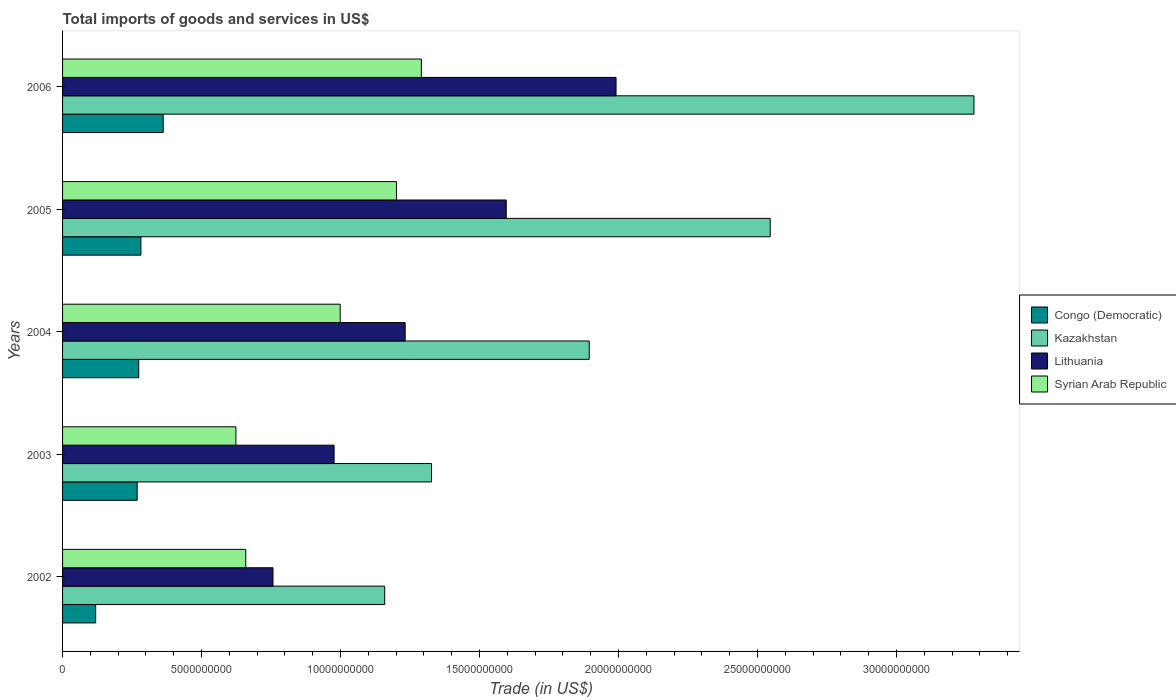Are the number of bars per tick equal to the number of legend labels?
Keep it short and to the point. Yes. How many bars are there on the 2nd tick from the top?
Give a very brief answer. 4. How many bars are there on the 1st tick from the bottom?
Your response must be concise. 4. What is the total imports of goods and services in Congo (Democratic) in 2006?
Ensure brevity in your answer.  3.62e+09. Across all years, what is the maximum total imports of goods and services in Congo (Democratic)?
Provide a short and direct response. 3.62e+09. Across all years, what is the minimum total imports of goods and services in Congo (Democratic)?
Ensure brevity in your answer.  1.19e+09. In which year was the total imports of goods and services in Kazakhstan maximum?
Offer a very short reply. 2006. What is the total total imports of goods and services in Lithuania in the graph?
Give a very brief answer. 6.55e+1. What is the difference between the total imports of goods and services in Congo (Democratic) in 2004 and that in 2005?
Keep it short and to the point. -7.91e+07. What is the difference between the total imports of goods and services in Lithuania in 2005 and the total imports of goods and services in Congo (Democratic) in 2003?
Your answer should be compact. 1.33e+1. What is the average total imports of goods and services in Kazakhstan per year?
Offer a very short reply. 2.04e+1. In the year 2006, what is the difference between the total imports of goods and services in Congo (Democratic) and total imports of goods and services in Kazakhstan?
Your answer should be compact. -2.92e+1. What is the ratio of the total imports of goods and services in Congo (Democratic) in 2003 to that in 2006?
Provide a succinct answer. 0.74. Is the total imports of goods and services in Lithuania in 2002 less than that in 2006?
Keep it short and to the point. Yes. Is the difference between the total imports of goods and services in Congo (Democratic) in 2002 and 2004 greater than the difference between the total imports of goods and services in Kazakhstan in 2002 and 2004?
Provide a short and direct response. Yes. What is the difference between the highest and the second highest total imports of goods and services in Kazakhstan?
Give a very brief answer. 7.33e+09. What is the difference between the highest and the lowest total imports of goods and services in Kazakhstan?
Provide a succinct answer. 2.12e+1. In how many years, is the total imports of goods and services in Syrian Arab Republic greater than the average total imports of goods and services in Syrian Arab Republic taken over all years?
Your answer should be very brief. 3. Is the sum of the total imports of goods and services in Kazakhstan in 2002 and 2006 greater than the maximum total imports of goods and services in Lithuania across all years?
Offer a terse response. Yes. Is it the case that in every year, the sum of the total imports of goods and services in Syrian Arab Republic and total imports of goods and services in Lithuania is greater than the sum of total imports of goods and services in Congo (Democratic) and total imports of goods and services in Kazakhstan?
Give a very brief answer. No. What does the 4th bar from the top in 2006 represents?
Keep it short and to the point. Congo (Democratic). What does the 1st bar from the bottom in 2004 represents?
Your answer should be compact. Congo (Democratic). Does the graph contain grids?
Ensure brevity in your answer.  No. How many legend labels are there?
Your answer should be very brief. 4. What is the title of the graph?
Keep it short and to the point. Total imports of goods and services in US$. What is the label or title of the X-axis?
Your answer should be compact. Trade (in US$). What is the Trade (in US$) in Congo (Democratic) in 2002?
Provide a succinct answer. 1.19e+09. What is the Trade (in US$) of Kazakhstan in 2002?
Your response must be concise. 1.16e+1. What is the Trade (in US$) in Lithuania in 2002?
Provide a succinct answer. 7.57e+09. What is the Trade (in US$) in Syrian Arab Republic in 2002?
Give a very brief answer. 6.59e+09. What is the Trade (in US$) of Congo (Democratic) in 2003?
Your response must be concise. 2.68e+09. What is the Trade (in US$) in Kazakhstan in 2003?
Offer a terse response. 1.33e+1. What is the Trade (in US$) of Lithuania in 2003?
Your response must be concise. 9.77e+09. What is the Trade (in US$) of Syrian Arab Republic in 2003?
Your response must be concise. 6.24e+09. What is the Trade (in US$) in Congo (Democratic) in 2004?
Give a very brief answer. 2.74e+09. What is the Trade (in US$) of Kazakhstan in 2004?
Offer a terse response. 1.89e+1. What is the Trade (in US$) of Lithuania in 2004?
Keep it short and to the point. 1.23e+1. What is the Trade (in US$) of Syrian Arab Republic in 2004?
Keep it short and to the point. 9.99e+09. What is the Trade (in US$) of Congo (Democratic) in 2005?
Provide a succinct answer. 2.82e+09. What is the Trade (in US$) in Kazakhstan in 2005?
Your answer should be very brief. 2.55e+1. What is the Trade (in US$) in Lithuania in 2005?
Provide a short and direct response. 1.60e+1. What is the Trade (in US$) in Syrian Arab Republic in 2005?
Your answer should be very brief. 1.20e+1. What is the Trade (in US$) in Congo (Democratic) in 2006?
Ensure brevity in your answer.  3.62e+09. What is the Trade (in US$) in Kazakhstan in 2006?
Provide a succinct answer. 3.28e+1. What is the Trade (in US$) in Lithuania in 2006?
Your answer should be very brief. 1.99e+1. What is the Trade (in US$) in Syrian Arab Republic in 2006?
Keep it short and to the point. 1.29e+1. Across all years, what is the maximum Trade (in US$) of Congo (Democratic)?
Your response must be concise. 3.62e+09. Across all years, what is the maximum Trade (in US$) in Kazakhstan?
Make the answer very short. 3.28e+1. Across all years, what is the maximum Trade (in US$) in Lithuania?
Make the answer very short. 1.99e+1. Across all years, what is the maximum Trade (in US$) in Syrian Arab Republic?
Offer a terse response. 1.29e+1. Across all years, what is the minimum Trade (in US$) in Congo (Democratic)?
Keep it short and to the point. 1.19e+09. Across all years, what is the minimum Trade (in US$) in Kazakhstan?
Offer a very short reply. 1.16e+1. Across all years, what is the minimum Trade (in US$) in Lithuania?
Provide a short and direct response. 7.57e+09. Across all years, what is the minimum Trade (in US$) of Syrian Arab Republic?
Your answer should be very brief. 6.24e+09. What is the total Trade (in US$) of Congo (Democratic) in the graph?
Give a very brief answer. 1.31e+1. What is the total Trade (in US$) in Kazakhstan in the graph?
Offer a terse response. 1.02e+11. What is the total Trade (in US$) of Lithuania in the graph?
Provide a succinct answer. 6.55e+1. What is the total Trade (in US$) in Syrian Arab Republic in the graph?
Give a very brief answer. 4.77e+1. What is the difference between the Trade (in US$) in Congo (Democratic) in 2002 and that in 2003?
Provide a succinct answer. -1.49e+09. What is the difference between the Trade (in US$) of Kazakhstan in 2002 and that in 2003?
Give a very brief answer. -1.68e+09. What is the difference between the Trade (in US$) in Lithuania in 2002 and that in 2003?
Offer a terse response. -2.20e+09. What is the difference between the Trade (in US$) in Syrian Arab Republic in 2002 and that in 2003?
Your response must be concise. 3.56e+08. What is the difference between the Trade (in US$) in Congo (Democratic) in 2002 and that in 2004?
Provide a succinct answer. -1.55e+09. What is the difference between the Trade (in US$) in Kazakhstan in 2002 and that in 2004?
Offer a terse response. -7.36e+09. What is the difference between the Trade (in US$) of Lithuania in 2002 and that in 2004?
Make the answer very short. -4.76e+09. What is the difference between the Trade (in US$) of Syrian Arab Republic in 2002 and that in 2004?
Ensure brevity in your answer.  -3.40e+09. What is the difference between the Trade (in US$) of Congo (Democratic) in 2002 and that in 2005?
Your response must be concise. -1.63e+09. What is the difference between the Trade (in US$) of Kazakhstan in 2002 and that in 2005?
Your answer should be very brief. -1.39e+1. What is the difference between the Trade (in US$) of Lithuania in 2002 and that in 2005?
Give a very brief answer. -8.39e+09. What is the difference between the Trade (in US$) of Syrian Arab Republic in 2002 and that in 2005?
Your answer should be compact. -5.42e+09. What is the difference between the Trade (in US$) of Congo (Democratic) in 2002 and that in 2006?
Make the answer very short. -2.43e+09. What is the difference between the Trade (in US$) of Kazakhstan in 2002 and that in 2006?
Your answer should be compact. -2.12e+1. What is the difference between the Trade (in US$) in Lithuania in 2002 and that in 2006?
Offer a very short reply. -1.23e+1. What is the difference between the Trade (in US$) in Syrian Arab Republic in 2002 and that in 2006?
Keep it short and to the point. -6.32e+09. What is the difference between the Trade (in US$) in Congo (Democratic) in 2003 and that in 2004?
Your response must be concise. -5.58e+07. What is the difference between the Trade (in US$) of Kazakhstan in 2003 and that in 2004?
Offer a terse response. -5.67e+09. What is the difference between the Trade (in US$) of Lithuania in 2003 and that in 2004?
Provide a short and direct response. -2.56e+09. What is the difference between the Trade (in US$) in Syrian Arab Republic in 2003 and that in 2004?
Give a very brief answer. -3.75e+09. What is the difference between the Trade (in US$) in Congo (Democratic) in 2003 and that in 2005?
Offer a very short reply. -1.35e+08. What is the difference between the Trade (in US$) in Kazakhstan in 2003 and that in 2005?
Keep it short and to the point. -1.22e+1. What is the difference between the Trade (in US$) in Lithuania in 2003 and that in 2005?
Your answer should be compact. -6.19e+09. What is the difference between the Trade (in US$) in Syrian Arab Republic in 2003 and that in 2005?
Give a very brief answer. -5.78e+09. What is the difference between the Trade (in US$) in Congo (Democratic) in 2003 and that in 2006?
Make the answer very short. -9.36e+08. What is the difference between the Trade (in US$) in Kazakhstan in 2003 and that in 2006?
Your response must be concise. -1.95e+1. What is the difference between the Trade (in US$) in Lithuania in 2003 and that in 2006?
Your response must be concise. -1.01e+1. What is the difference between the Trade (in US$) of Syrian Arab Republic in 2003 and that in 2006?
Provide a succinct answer. -6.67e+09. What is the difference between the Trade (in US$) of Congo (Democratic) in 2004 and that in 2005?
Make the answer very short. -7.91e+07. What is the difference between the Trade (in US$) in Kazakhstan in 2004 and that in 2005?
Your answer should be compact. -6.51e+09. What is the difference between the Trade (in US$) in Lithuania in 2004 and that in 2005?
Keep it short and to the point. -3.64e+09. What is the difference between the Trade (in US$) of Syrian Arab Republic in 2004 and that in 2005?
Provide a short and direct response. -2.02e+09. What is the difference between the Trade (in US$) of Congo (Democratic) in 2004 and that in 2006?
Your answer should be compact. -8.81e+08. What is the difference between the Trade (in US$) in Kazakhstan in 2004 and that in 2006?
Keep it short and to the point. -1.38e+1. What is the difference between the Trade (in US$) of Lithuania in 2004 and that in 2006?
Provide a succinct answer. -7.59e+09. What is the difference between the Trade (in US$) in Syrian Arab Republic in 2004 and that in 2006?
Offer a very short reply. -2.92e+09. What is the difference between the Trade (in US$) of Congo (Democratic) in 2005 and that in 2006?
Keep it short and to the point. -8.02e+08. What is the difference between the Trade (in US$) of Kazakhstan in 2005 and that in 2006?
Make the answer very short. -7.33e+09. What is the difference between the Trade (in US$) in Lithuania in 2005 and that in 2006?
Offer a very short reply. -3.95e+09. What is the difference between the Trade (in US$) of Syrian Arab Republic in 2005 and that in 2006?
Make the answer very short. -8.95e+08. What is the difference between the Trade (in US$) in Congo (Democratic) in 2002 and the Trade (in US$) in Kazakhstan in 2003?
Your answer should be compact. -1.21e+1. What is the difference between the Trade (in US$) in Congo (Democratic) in 2002 and the Trade (in US$) in Lithuania in 2003?
Provide a short and direct response. -8.58e+09. What is the difference between the Trade (in US$) of Congo (Democratic) in 2002 and the Trade (in US$) of Syrian Arab Republic in 2003?
Provide a short and direct response. -5.05e+09. What is the difference between the Trade (in US$) in Kazakhstan in 2002 and the Trade (in US$) in Lithuania in 2003?
Your response must be concise. 1.82e+09. What is the difference between the Trade (in US$) of Kazakhstan in 2002 and the Trade (in US$) of Syrian Arab Republic in 2003?
Give a very brief answer. 5.35e+09. What is the difference between the Trade (in US$) of Lithuania in 2002 and the Trade (in US$) of Syrian Arab Republic in 2003?
Give a very brief answer. 1.33e+09. What is the difference between the Trade (in US$) of Congo (Democratic) in 2002 and the Trade (in US$) of Kazakhstan in 2004?
Provide a short and direct response. -1.78e+1. What is the difference between the Trade (in US$) in Congo (Democratic) in 2002 and the Trade (in US$) in Lithuania in 2004?
Your answer should be very brief. -1.11e+1. What is the difference between the Trade (in US$) of Congo (Democratic) in 2002 and the Trade (in US$) of Syrian Arab Republic in 2004?
Give a very brief answer. -8.80e+09. What is the difference between the Trade (in US$) of Kazakhstan in 2002 and the Trade (in US$) of Lithuania in 2004?
Ensure brevity in your answer.  -7.37e+08. What is the difference between the Trade (in US$) of Kazakhstan in 2002 and the Trade (in US$) of Syrian Arab Republic in 2004?
Ensure brevity in your answer.  1.60e+09. What is the difference between the Trade (in US$) of Lithuania in 2002 and the Trade (in US$) of Syrian Arab Republic in 2004?
Your response must be concise. -2.42e+09. What is the difference between the Trade (in US$) in Congo (Democratic) in 2002 and the Trade (in US$) in Kazakhstan in 2005?
Offer a very short reply. -2.43e+1. What is the difference between the Trade (in US$) of Congo (Democratic) in 2002 and the Trade (in US$) of Lithuania in 2005?
Your answer should be very brief. -1.48e+1. What is the difference between the Trade (in US$) of Congo (Democratic) in 2002 and the Trade (in US$) of Syrian Arab Republic in 2005?
Provide a short and direct response. -1.08e+1. What is the difference between the Trade (in US$) in Kazakhstan in 2002 and the Trade (in US$) in Lithuania in 2005?
Give a very brief answer. -4.37e+09. What is the difference between the Trade (in US$) in Kazakhstan in 2002 and the Trade (in US$) in Syrian Arab Republic in 2005?
Give a very brief answer. -4.23e+08. What is the difference between the Trade (in US$) in Lithuania in 2002 and the Trade (in US$) in Syrian Arab Republic in 2005?
Your answer should be very brief. -4.44e+09. What is the difference between the Trade (in US$) of Congo (Democratic) in 2002 and the Trade (in US$) of Kazakhstan in 2006?
Give a very brief answer. -3.16e+1. What is the difference between the Trade (in US$) in Congo (Democratic) in 2002 and the Trade (in US$) in Lithuania in 2006?
Offer a terse response. -1.87e+1. What is the difference between the Trade (in US$) in Congo (Democratic) in 2002 and the Trade (in US$) in Syrian Arab Republic in 2006?
Offer a very short reply. -1.17e+1. What is the difference between the Trade (in US$) of Kazakhstan in 2002 and the Trade (in US$) of Lithuania in 2006?
Provide a succinct answer. -8.32e+09. What is the difference between the Trade (in US$) in Kazakhstan in 2002 and the Trade (in US$) in Syrian Arab Republic in 2006?
Make the answer very short. -1.32e+09. What is the difference between the Trade (in US$) in Lithuania in 2002 and the Trade (in US$) in Syrian Arab Republic in 2006?
Give a very brief answer. -5.34e+09. What is the difference between the Trade (in US$) of Congo (Democratic) in 2003 and the Trade (in US$) of Kazakhstan in 2004?
Ensure brevity in your answer.  -1.63e+1. What is the difference between the Trade (in US$) in Congo (Democratic) in 2003 and the Trade (in US$) in Lithuania in 2004?
Provide a short and direct response. -9.64e+09. What is the difference between the Trade (in US$) of Congo (Democratic) in 2003 and the Trade (in US$) of Syrian Arab Republic in 2004?
Offer a very short reply. -7.30e+09. What is the difference between the Trade (in US$) of Kazakhstan in 2003 and the Trade (in US$) of Lithuania in 2004?
Your answer should be compact. 9.47e+08. What is the difference between the Trade (in US$) in Kazakhstan in 2003 and the Trade (in US$) in Syrian Arab Republic in 2004?
Your answer should be very brief. 3.29e+09. What is the difference between the Trade (in US$) in Lithuania in 2003 and the Trade (in US$) in Syrian Arab Republic in 2004?
Your answer should be very brief. -2.18e+08. What is the difference between the Trade (in US$) in Congo (Democratic) in 2003 and the Trade (in US$) in Kazakhstan in 2005?
Ensure brevity in your answer.  -2.28e+1. What is the difference between the Trade (in US$) of Congo (Democratic) in 2003 and the Trade (in US$) of Lithuania in 2005?
Provide a succinct answer. -1.33e+1. What is the difference between the Trade (in US$) in Congo (Democratic) in 2003 and the Trade (in US$) in Syrian Arab Republic in 2005?
Make the answer very short. -9.33e+09. What is the difference between the Trade (in US$) in Kazakhstan in 2003 and the Trade (in US$) in Lithuania in 2005?
Ensure brevity in your answer.  -2.69e+09. What is the difference between the Trade (in US$) in Kazakhstan in 2003 and the Trade (in US$) in Syrian Arab Republic in 2005?
Keep it short and to the point. 1.26e+09. What is the difference between the Trade (in US$) of Lithuania in 2003 and the Trade (in US$) of Syrian Arab Republic in 2005?
Your answer should be compact. -2.24e+09. What is the difference between the Trade (in US$) in Congo (Democratic) in 2003 and the Trade (in US$) in Kazakhstan in 2006?
Make the answer very short. -3.01e+1. What is the difference between the Trade (in US$) of Congo (Democratic) in 2003 and the Trade (in US$) of Lithuania in 2006?
Your response must be concise. -1.72e+1. What is the difference between the Trade (in US$) of Congo (Democratic) in 2003 and the Trade (in US$) of Syrian Arab Republic in 2006?
Offer a terse response. -1.02e+1. What is the difference between the Trade (in US$) of Kazakhstan in 2003 and the Trade (in US$) of Lithuania in 2006?
Keep it short and to the point. -6.64e+09. What is the difference between the Trade (in US$) of Kazakhstan in 2003 and the Trade (in US$) of Syrian Arab Republic in 2006?
Provide a short and direct response. 3.65e+08. What is the difference between the Trade (in US$) in Lithuania in 2003 and the Trade (in US$) in Syrian Arab Republic in 2006?
Offer a terse response. -3.14e+09. What is the difference between the Trade (in US$) in Congo (Democratic) in 2004 and the Trade (in US$) in Kazakhstan in 2005?
Keep it short and to the point. -2.27e+1. What is the difference between the Trade (in US$) of Congo (Democratic) in 2004 and the Trade (in US$) of Lithuania in 2005?
Your response must be concise. -1.32e+1. What is the difference between the Trade (in US$) of Congo (Democratic) in 2004 and the Trade (in US$) of Syrian Arab Republic in 2005?
Provide a short and direct response. -9.27e+09. What is the difference between the Trade (in US$) of Kazakhstan in 2004 and the Trade (in US$) of Lithuania in 2005?
Keep it short and to the point. 2.99e+09. What is the difference between the Trade (in US$) in Kazakhstan in 2004 and the Trade (in US$) in Syrian Arab Republic in 2005?
Your answer should be very brief. 6.93e+09. What is the difference between the Trade (in US$) in Lithuania in 2004 and the Trade (in US$) in Syrian Arab Republic in 2005?
Your answer should be very brief. 3.14e+08. What is the difference between the Trade (in US$) of Congo (Democratic) in 2004 and the Trade (in US$) of Kazakhstan in 2006?
Ensure brevity in your answer.  -3.00e+1. What is the difference between the Trade (in US$) of Congo (Democratic) in 2004 and the Trade (in US$) of Lithuania in 2006?
Your answer should be very brief. -1.72e+1. What is the difference between the Trade (in US$) in Congo (Democratic) in 2004 and the Trade (in US$) in Syrian Arab Republic in 2006?
Your answer should be compact. -1.02e+1. What is the difference between the Trade (in US$) of Kazakhstan in 2004 and the Trade (in US$) of Lithuania in 2006?
Your answer should be compact. -9.65e+08. What is the difference between the Trade (in US$) of Kazakhstan in 2004 and the Trade (in US$) of Syrian Arab Republic in 2006?
Make the answer very short. 6.04e+09. What is the difference between the Trade (in US$) in Lithuania in 2004 and the Trade (in US$) in Syrian Arab Republic in 2006?
Your answer should be very brief. -5.82e+08. What is the difference between the Trade (in US$) in Congo (Democratic) in 2005 and the Trade (in US$) in Kazakhstan in 2006?
Provide a succinct answer. -3.00e+1. What is the difference between the Trade (in US$) in Congo (Democratic) in 2005 and the Trade (in US$) in Lithuania in 2006?
Provide a short and direct response. -1.71e+1. What is the difference between the Trade (in US$) in Congo (Democratic) in 2005 and the Trade (in US$) in Syrian Arab Republic in 2006?
Provide a succinct answer. -1.01e+1. What is the difference between the Trade (in US$) in Kazakhstan in 2005 and the Trade (in US$) in Lithuania in 2006?
Offer a terse response. 5.55e+09. What is the difference between the Trade (in US$) of Kazakhstan in 2005 and the Trade (in US$) of Syrian Arab Republic in 2006?
Provide a succinct answer. 1.26e+1. What is the difference between the Trade (in US$) in Lithuania in 2005 and the Trade (in US$) in Syrian Arab Republic in 2006?
Provide a succinct answer. 3.05e+09. What is the average Trade (in US$) of Congo (Democratic) per year?
Keep it short and to the point. 2.61e+09. What is the average Trade (in US$) in Kazakhstan per year?
Provide a short and direct response. 2.04e+1. What is the average Trade (in US$) of Lithuania per year?
Keep it short and to the point. 1.31e+1. What is the average Trade (in US$) of Syrian Arab Republic per year?
Your answer should be very brief. 9.55e+09. In the year 2002, what is the difference between the Trade (in US$) of Congo (Democratic) and Trade (in US$) of Kazakhstan?
Make the answer very short. -1.04e+1. In the year 2002, what is the difference between the Trade (in US$) of Congo (Democratic) and Trade (in US$) of Lithuania?
Give a very brief answer. -6.38e+09. In the year 2002, what is the difference between the Trade (in US$) in Congo (Democratic) and Trade (in US$) in Syrian Arab Republic?
Ensure brevity in your answer.  -5.40e+09. In the year 2002, what is the difference between the Trade (in US$) in Kazakhstan and Trade (in US$) in Lithuania?
Your answer should be very brief. 4.02e+09. In the year 2002, what is the difference between the Trade (in US$) in Kazakhstan and Trade (in US$) in Syrian Arab Republic?
Offer a very short reply. 5.00e+09. In the year 2002, what is the difference between the Trade (in US$) in Lithuania and Trade (in US$) in Syrian Arab Republic?
Provide a succinct answer. 9.78e+08. In the year 2003, what is the difference between the Trade (in US$) of Congo (Democratic) and Trade (in US$) of Kazakhstan?
Offer a very short reply. -1.06e+1. In the year 2003, what is the difference between the Trade (in US$) in Congo (Democratic) and Trade (in US$) in Lithuania?
Keep it short and to the point. -7.09e+09. In the year 2003, what is the difference between the Trade (in US$) in Congo (Democratic) and Trade (in US$) in Syrian Arab Republic?
Give a very brief answer. -3.55e+09. In the year 2003, what is the difference between the Trade (in US$) of Kazakhstan and Trade (in US$) of Lithuania?
Your answer should be compact. 3.50e+09. In the year 2003, what is the difference between the Trade (in US$) of Kazakhstan and Trade (in US$) of Syrian Arab Republic?
Make the answer very short. 7.04e+09. In the year 2003, what is the difference between the Trade (in US$) in Lithuania and Trade (in US$) in Syrian Arab Republic?
Provide a succinct answer. 3.53e+09. In the year 2004, what is the difference between the Trade (in US$) of Congo (Democratic) and Trade (in US$) of Kazakhstan?
Provide a short and direct response. -1.62e+1. In the year 2004, what is the difference between the Trade (in US$) in Congo (Democratic) and Trade (in US$) in Lithuania?
Keep it short and to the point. -9.59e+09. In the year 2004, what is the difference between the Trade (in US$) in Congo (Democratic) and Trade (in US$) in Syrian Arab Republic?
Your response must be concise. -7.25e+09. In the year 2004, what is the difference between the Trade (in US$) in Kazakhstan and Trade (in US$) in Lithuania?
Your response must be concise. 6.62e+09. In the year 2004, what is the difference between the Trade (in US$) of Kazakhstan and Trade (in US$) of Syrian Arab Republic?
Offer a very short reply. 8.96e+09. In the year 2004, what is the difference between the Trade (in US$) of Lithuania and Trade (in US$) of Syrian Arab Republic?
Offer a terse response. 2.34e+09. In the year 2005, what is the difference between the Trade (in US$) in Congo (Democratic) and Trade (in US$) in Kazakhstan?
Offer a very short reply. -2.26e+1. In the year 2005, what is the difference between the Trade (in US$) of Congo (Democratic) and Trade (in US$) of Lithuania?
Provide a short and direct response. -1.31e+1. In the year 2005, what is the difference between the Trade (in US$) of Congo (Democratic) and Trade (in US$) of Syrian Arab Republic?
Ensure brevity in your answer.  -9.19e+09. In the year 2005, what is the difference between the Trade (in US$) of Kazakhstan and Trade (in US$) of Lithuania?
Keep it short and to the point. 9.50e+09. In the year 2005, what is the difference between the Trade (in US$) of Kazakhstan and Trade (in US$) of Syrian Arab Republic?
Provide a succinct answer. 1.34e+1. In the year 2005, what is the difference between the Trade (in US$) in Lithuania and Trade (in US$) in Syrian Arab Republic?
Provide a short and direct response. 3.95e+09. In the year 2006, what is the difference between the Trade (in US$) of Congo (Democratic) and Trade (in US$) of Kazakhstan?
Your answer should be very brief. -2.92e+1. In the year 2006, what is the difference between the Trade (in US$) of Congo (Democratic) and Trade (in US$) of Lithuania?
Offer a terse response. -1.63e+1. In the year 2006, what is the difference between the Trade (in US$) in Congo (Democratic) and Trade (in US$) in Syrian Arab Republic?
Your response must be concise. -9.29e+09. In the year 2006, what is the difference between the Trade (in US$) of Kazakhstan and Trade (in US$) of Lithuania?
Offer a very short reply. 1.29e+1. In the year 2006, what is the difference between the Trade (in US$) of Kazakhstan and Trade (in US$) of Syrian Arab Republic?
Make the answer very short. 1.99e+1. In the year 2006, what is the difference between the Trade (in US$) of Lithuania and Trade (in US$) of Syrian Arab Republic?
Offer a very short reply. 7.00e+09. What is the ratio of the Trade (in US$) in Congo (Democratic) in 2002 to that in 2003?
Keep it short and to the point. 0.44. What is the ratio of the Trade (in US$) of Kazakhstan in 2002 to that in 2003?
Give a very brief answer. 0.87. What is the ratio of the Trade (in US$) of Lithuania in 2002 to that in 2003?
Provide a succinct answer. 0.77. What is the ratio of the Trade (in US$) of Syrian Arab Republic in 2002 to that in 2003?
Your answer should be compact. 1.06. What is the ratio of the Trade (in US$) of Congo (Democratic) in 2002 to that in 2004?
Your answer should be very brief. 0.43. What is the ratio of the Trade (in US$) in Kazakhstan in 2002 to that in 2004?
Keep it short and to the point. 0.61. What is the ratio of the Trade (in US$) in Lithuania in 2002 to that in 2004?
Your answer should be compact. 0.61. What is the ratio of the Trade (in US$) in Syrian Arab Republic in 2002 to that in 2004?
Give a very brief answer. 0.66. What is the ratio of the Trade (in US$) in Congo (Democratic) in 2002 to that in 2005?
Your response must be concise. 0.42. What is the ratio of the Trade (in US$) of Kazakhstan in 2002 to that in 2005?
Offer a terse response. 0.46. What is the ratio of the Trade (in US$) of Lithuania in 2002 to that in 2005?
Your answer should be compact. 0.47. What is the ratio of the Trade (in US$) in Syrian Arab Republic in 2002 to that in 2005?
Your answer should be very brief. 0.55. What is the ratio of the Trade (in US$) in Congo (Democratic) in 2002 to that in 2006?
Your answer should be very brief. 0.33. What is the ratio of the Trade (in US$) in Kazakhstan in 2002 to that in 2006?
Offer a very short reply. 0.35. What is the ratio of the Trade (in US$) of Lithuania in 2002 to that in 2006?
Give a very brief answer. 0.38. What is the ratio of the Trade (in US$) in Syrian Arab Republic in 2002 to that in 2006?
Provide a succinct answer. 0.51. What is the ratio of the Trade (in US$) in Congo (Democratic) in 2003 to that in 2004?
Ensure brevity in your answer.  0.98. What is the ratio of the Trade (in US$) in Kazakhstan in 2003 to that in 2004?
Offer a terse response. 0.7. What is the ratio of the Trade (in US$) of Lithuania in 2003 to that in 2004?
Provide a succinct answer. 0.79. What is the ratio of the Trade (in US$) in Syrian Arab Republic in 2003 to that in 2004?
Provide a short and direct response. 0.62. What is the ratio of the Trade (in US$) in Congo (Democratic) in 2003 to that in 2005?
Ensure brevity in your answer.  0.95. What is the ratio of the Trade (in US$) of Kazakhstan in 2003 to that in 2005?
Give a very brief answer. 0.52. What is the ratio of the Trade (in US$) in Lithuania in 2003 to that in 2005?
Ensure brevity in your answer.  0.61. What is the ratio of the Trade (in US$) in Syrian Arab Republic in 2003 to that in 2005?
Offer a terse response. 0.52. What is the ratio of the Trade (in US$) of Congo (Democratic) in 2003 to that in 2006?
Offer a very short reply. 0.74. What is the ratio of the Trade (in US$) of Kazakhstan in 2003 to that in 2006?
Give a very brief answer. 0.4. What is the ratio of the Trade (in US$) of Lithuania in 2003 to that in 2006?
Keep it short and to the point. 0.49. What is the ratio of the Trade (in US$) in Syrian Arab Republic in 2003 to that in 2006?
Keep it short and to the point. 0.48. What is the ratio of the Trade (in US$) of Kazakhstan in 2004 to that in 2005?
Make the answer very short. 0.74. What is the ratio of the Trade (in US$) in Lithuania in 2004 to that in 2005?
Your response must be concise. 0.77. What is the ratio of the Trade (in US$) in Syrian Arab Republic in 2004 to that in 2005?
Make the answer very short. 0.83. What is the ratio of the Trade (in US$) in Congo (Democratic) in 2004 to that in 2006?
Keep it short and to the point. 0.76. What is the ratio of the Trade (in US$) of Kazakhstan in 2004 to that in 2006?
Provide a succinct answer. 0.58. What is the ratio of the Trade (in US$) of Lithuania in 2004 to that in 2006?
Your answer should be compact. 0.62. What is the ratio of the Trade (in US$) of Syrian Arab Republic in 2004 to that in 2006?
Offer a very short reply. 0.77. What is the ratio of the Trade (in US$) in Congo (Democratic) in 2005 to that in 2006?
Make the answer very short. 0.78. What is the ratio of the Trade (in US$) in Kazakhstan in 2005 to that in 2006?
Your answer should be very brief. 0.78. What is the ratio of the Trade (in US$) of Lithuania in 2005 to that in 2006?
Your response must be concise. 0.8. What is the ratio of the Trade (in US$) in Syrian Arab Republic in 2005 to that in 2006?
Provide a short and direct response. 0.93. What is the difference between the highest and the second highest Trade (in US$) of Congo (Democratic)?
Your answer should be compact. 8.02e+08. What is the difference between the highest and the second highest Trade (in US$) in Kazakhstan?
Provide a short and direct response. 7.33e+09. What is the difference between the highest and the second highest Trade (in US$) of Lithuania?
Offer a terse response. 3.95e+09. What is the difference between the highest and the second highest Trade (in US$) in Syrian Arab Republic?
Provide a succinct answer. 8.95e+08. What is the difference between the highest and the lowest Trade (in US$) of Congo (Democratic)?
Give a very brief answer. 2.43e+09. What is the difference between the highest and the lowest Trade (in US$) in Kazakhstan?
Keep it short and to the point. 2.12e+1. What is the difference between the highest and the lowest Trade (in US$) in Lithuania?
Offer a very short reply. 1.23e+1. What is the difference between the highest and the lowest Trade (in US$) in Syrian Arab Republic?
Provide a succinct answer. 6.67e+09. 